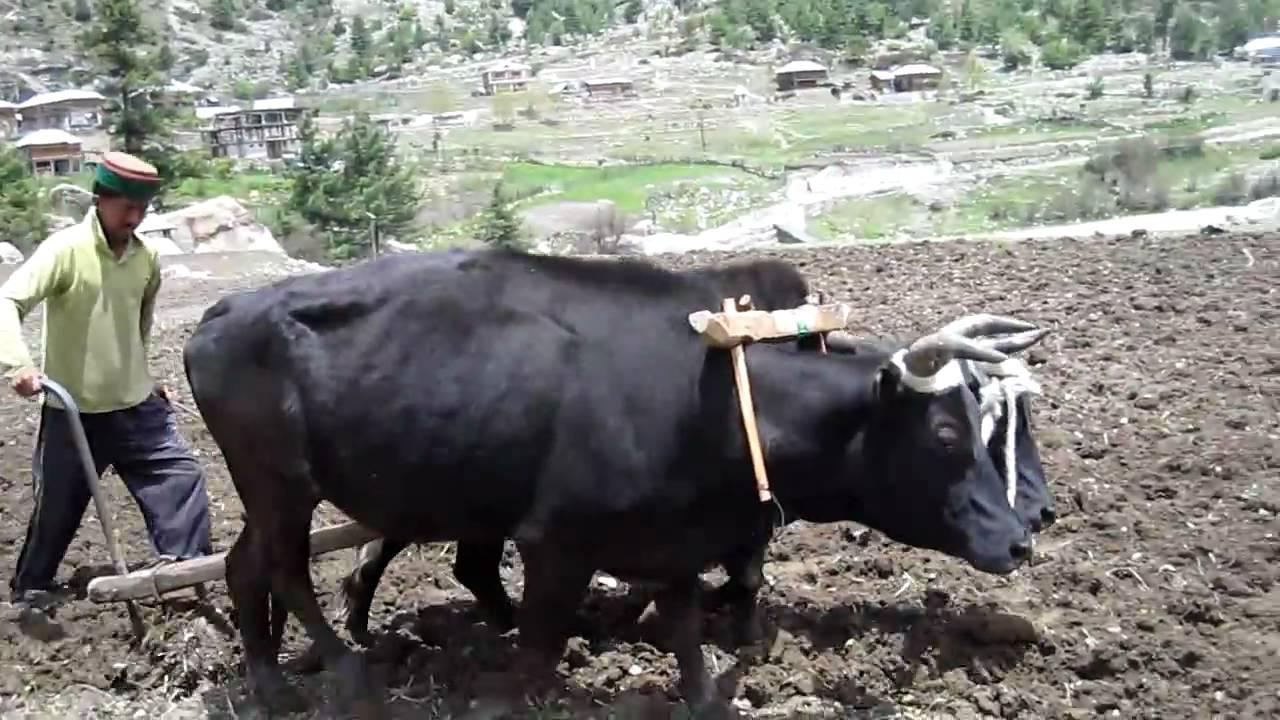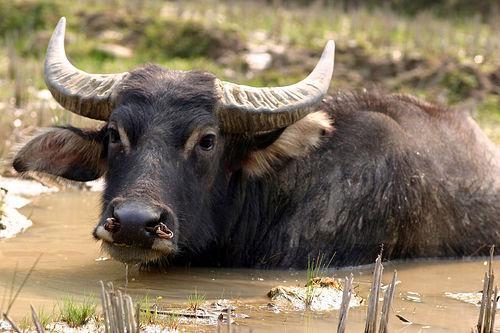The first image is the image on the left, the second image is the image on the right. For the images shown, is this caption "One man steering a plow is behind two oxen pulling the plow." true? Answer yes or no. Yes. The first image is the image on the left, the second image is the image on the right. Analyze the images presented: Is the assertion "The left image shows a man walking behind a pair of cattle attached to a farming implement ." valid? Answer yes or no. Yes. 